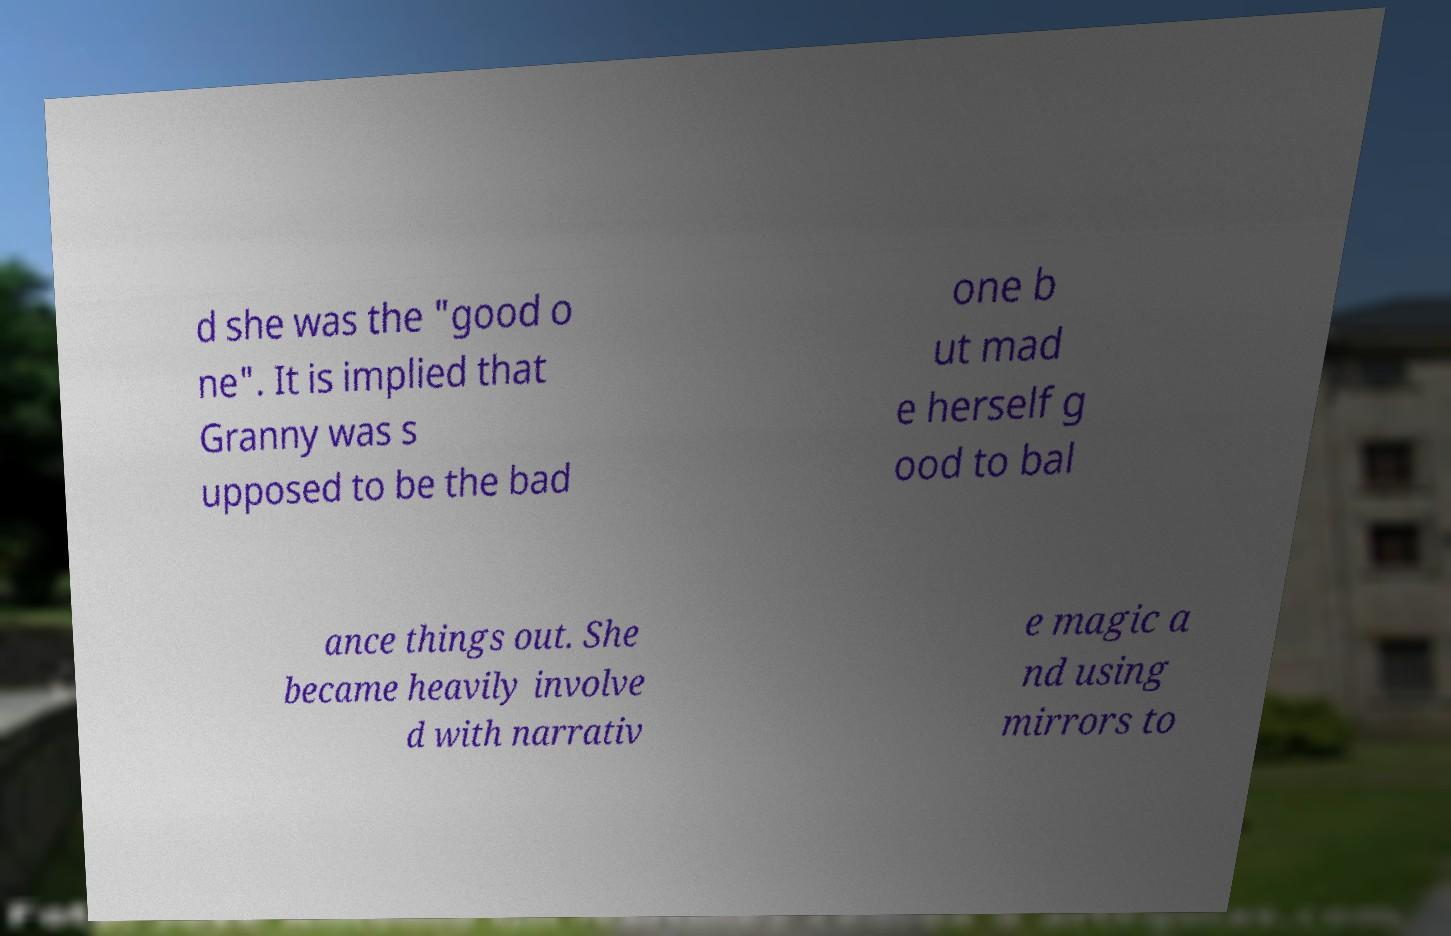Please read and relay the text visible in this image. What does it say? d she was the "good o ne". It is implied that Granny was s upposed to be the bad one b ut mad e herself g ood to bal ance things out. She became heavily involve d with narrativ e magic a nd using mirrors to 